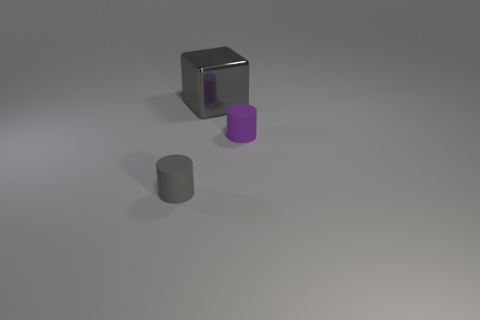Add 1 large gray cubes. How many objects exist? 4 Subtract all cylinders. How many objects are left? 1 Subtract 0 cyan cylinders. How many objects are left? 3 Subtract all tiny brown matte spheres. Subtract all shiny objects. How many objects are left? 2 Add 3 tiny cylinders. How many tiny cylinders are left? 5 Add 1 cyan matte cubes. How many cyan matte cubes exist? 1 